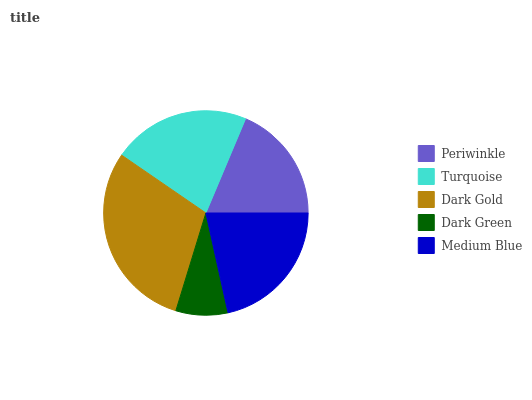Is Dark Green the minimum?
Answer yes or no. Yes. Is Dark Gold the maximum?
Answer yes or no. Yes. Is Turquoise the minimum?
Answer yes or no. No. Is Turquoise the maximum?
Answer yes or no. No. Is Turquoise greater than Periwinkle?
Answer yes or no. Yes. Is Periwinkle less than Turquoise?
Answer yes or no. Yes. Is Periwinkle greater than Turquoise?
Answer yes or no. No. Is Turquoise less than Periwinkle?
Answer yes or no. No. Is Medium Blue the high median?
Answer yes or no. Yes. Is Medium Blue the low median?
Answer yes or no. Yes. Is Dark Green the high median?
Answer yes or no. No. Is Dark Green the low median?
Answer yes or no. No. 